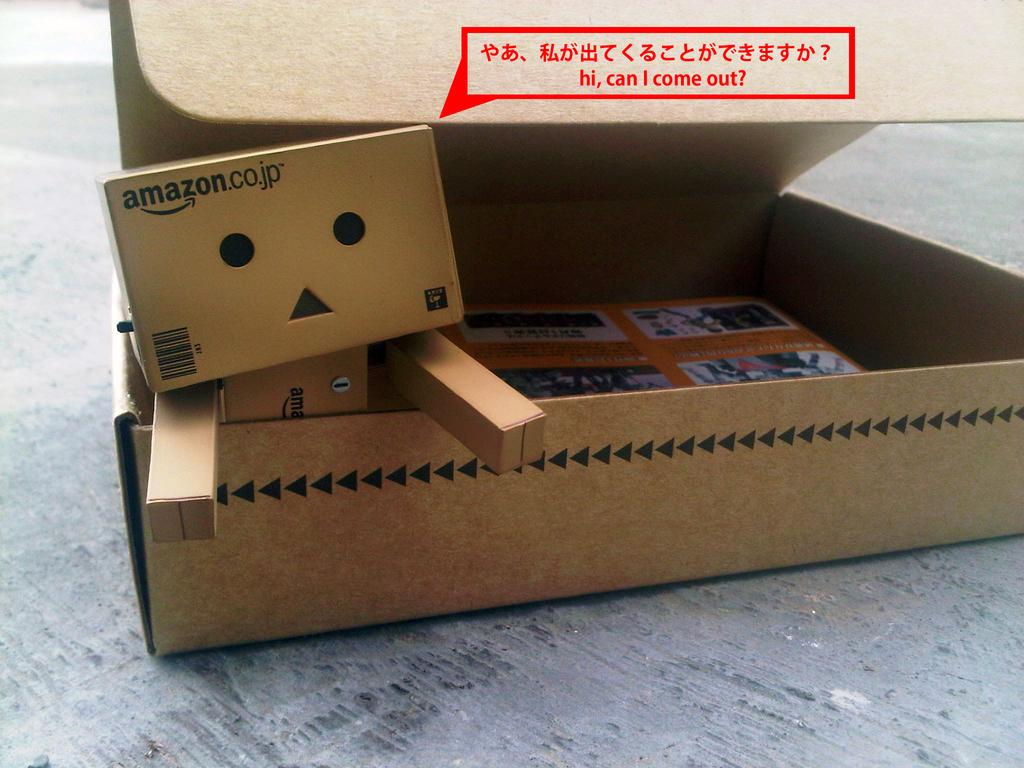<image>
Share a concise interpretation of the image provided. The cute little amazon cardboard box robot wants out of the box. 